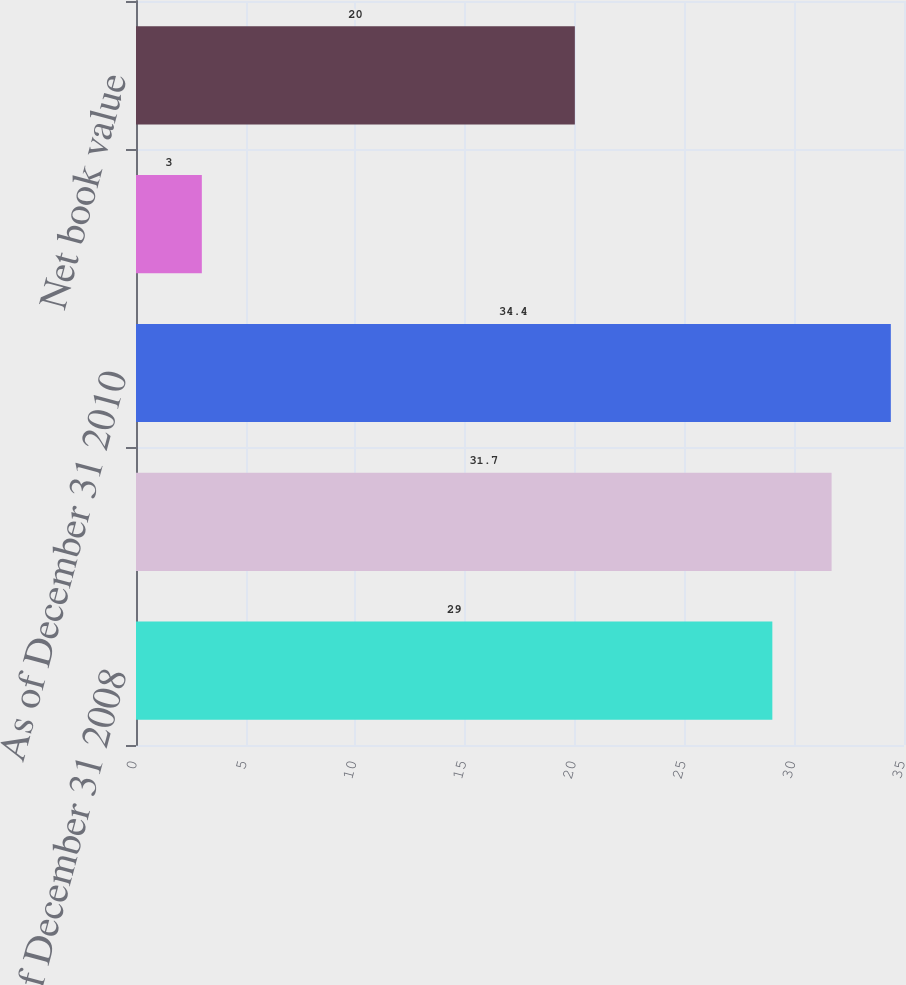Convert chart to OTSL. <chart><loc_0><loc_0><loc_500><loc_500><bar_chart><fcel>As of December 31 2008<fcel>As of December 31 2009<fcel>As of December 31 2010<fcel>Amortization<fcel>Net book value<nl><fcel>29<fcel>31.7<fcel>34.4<fcel>3<fcel>20<nl></chart> 